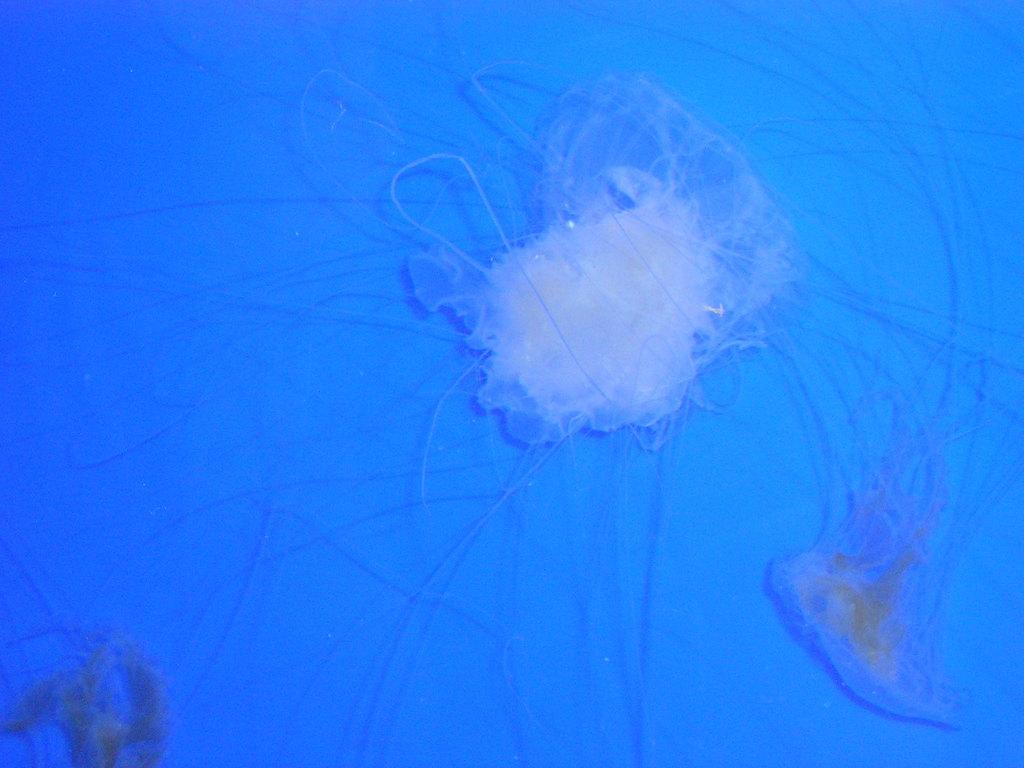What types of animals are present in the image? There are marine species in the image. What color is the background of the image? The background of the image is blue. What type of slave can be seen in the image? There is no slave present in the image; it features marine species. What type of drug can be seen in the image? There is no drug present in the image; it features marine species. 